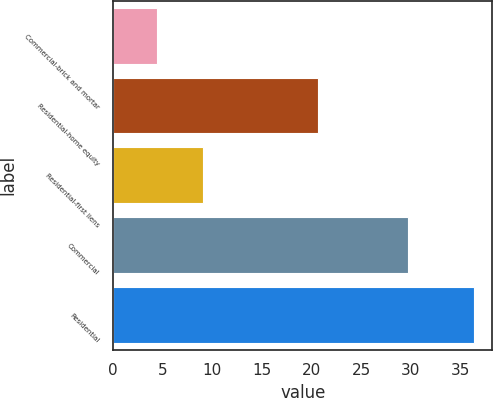Convert chart. <chart><loc_0><loc_0><loc_500><loc_500><bar_chart><fcel>Commercial-brick and mortar<fcel>Residential-home equity<fcel>Residential-first liens<fcel>Commercial<fcel>Residential<nl><fcel>4.4<fcel>20.7<fcel>9.1<fcel>29.7<fcel>36.4<nl></chart> 